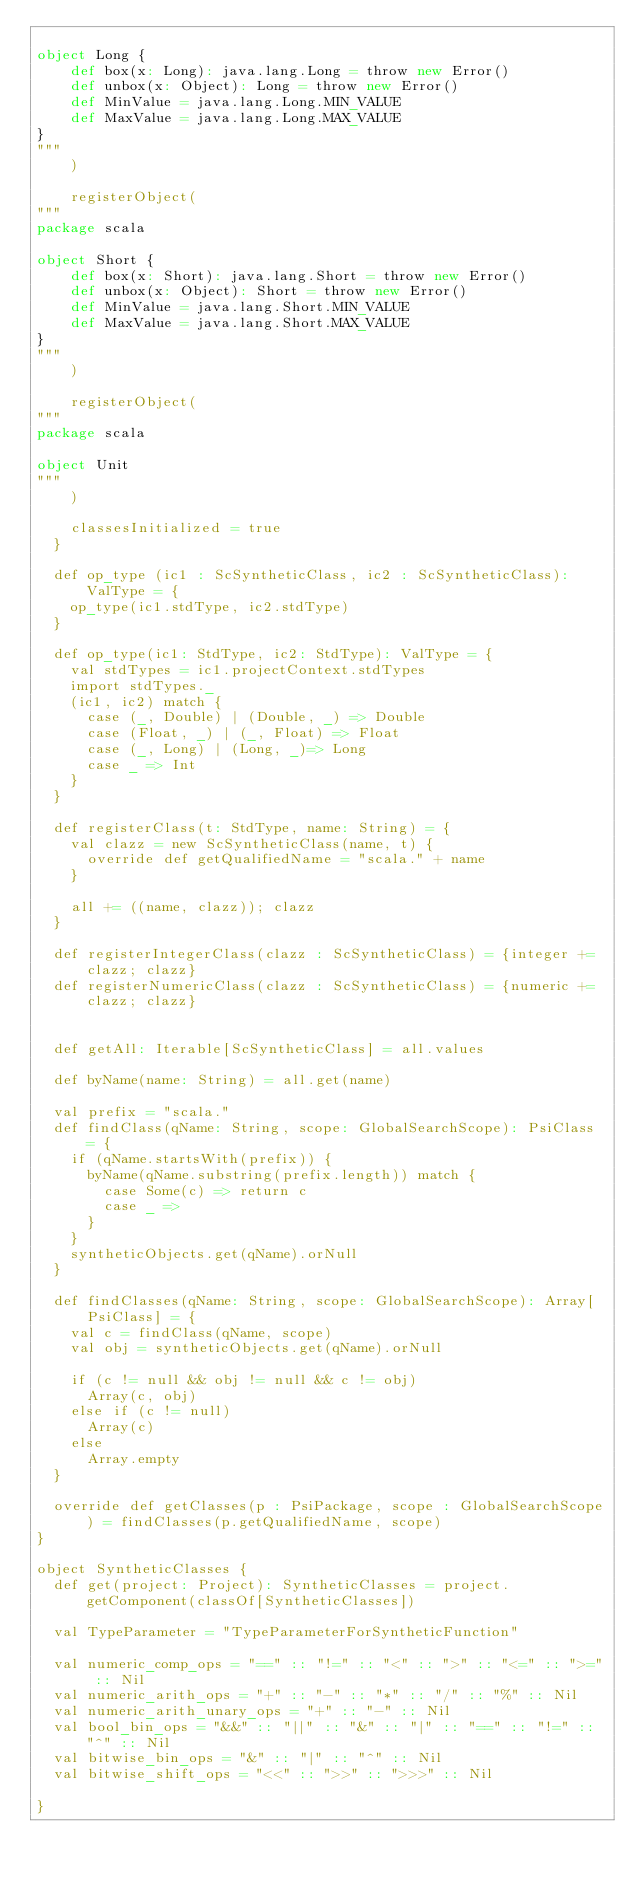<code> <loc_0><loc_0><loc_500><loc_500><_Scala_>
object Long {
 	def box(x: Long): java.lang.Long = throw new Error()
 	def unbox(x: Object): Long = throw new Error()
 	def MinValue = java.lang.Long.MIN_VALUE
 	def MaxValue = java.lang.Long.MAX_VALUE
}
"""
    )

    registerObject(
"""
package scala

object Short {
 	def box(x: Short): java.lang.Short = throw new Error()
 	def unbox(x: Object): Short = throw new Error()
 	def MinValue = java.lang.Short.MIN_VALUE
 	def MaxValue = java.lang.Short.MAX_VALUE
}
"""
    )

    registerObject(
"""
package scala

object Unit
"""
    )

    classesInitialized = true
  }

  def op_type (ic1 : ScSyntheticClass, ic2 : ScSyntheticClass): ValType = {
    op_type(ic1.stdType, ic2.stdType)
  }

  def op_type(ic1: StdType, ic2: StdType): ValType = {
    val stdTypes = ic1.projectContext.stdTypes
    import stdTypes._
    (ic1, ic2) match {
      case (_, Double) | (Double, _) => Double
      case (Float, _) | (_, Float) => Float
      case (_, Long) | (Long, _)=> Long
      case _ => Int
    }
  }

  def registerClass(t: StdType, name: String) = {
    val clazz = new ScSyntheticClass(name, t) {
      override def getQualifiedName = "scala." + name
    }

    all += ((name, clazz)); clazz
  }

  def registerIntegerClass(clazz : ScSyntheticClass) = {integer += clazz; clazz}
  def registerNumericClass(clazz : ScSyntheticClass) = {numeric += clazz; clazz}


  def getAll: Iterable[ScSyntheticClass] = all.values

  def byName(name: String) = all.get(name)

  val prefix = "scala."
  def findClass(qName: String, scope: GlobalSearchScope): PsiClass = {
    if (qName.startsWith(prefix)) {
      byName(qName.substring(prefix.length)) match {
        case Some(c) => return c
        case _ =>
      }
    }
    syntheticObjects.get(qName).orNull
  }

  def findClasses(qName: String, scope: GlobalSearchScope): Array[PsiClass] = {
    val c = findClass(qName, scope)
    val obj = syntheticObjects.get(qName).orNull

    if (c != null && obj != null && c != obj)
      Array(c, obj)
    else if (c != null)
      Array(c)
    else
      Array.empty
  }

  override def getClasses(p : PsiPackage, scope : GlobalSearchScope) = findClasses(p.getQualifiedName, scope)
}

object SyntheticClasses {
  def get(project: Project): SyntheticClasses = project.getComponent(classOf[SyntheticClasses])

  val TypeParameter = "TypeParameterForSyntheticFunction"

  val numeric_comp_ops = "==" :: "!=" :: "<" :: ">" :: "<=" :: ">=" :: Nil
  val numeric_arith_ops = "+" :: "-" :: "*" :: "/" :: "%" :: Nil
  val numeric_arith_unary_ops = "+" :: "-" :: Nil
  val bool_bin_ops = "&&" :: "||" :: "&" :: "|" :: "==" :: "!=" :: "^" :: Nil
  val bitwise_bin_ops = "&" :: "|" :: "^" :: Nil
  val bitwise_shift_ops = "<<" :: ">>" :: ">>>" :: Nil

}

</code> 